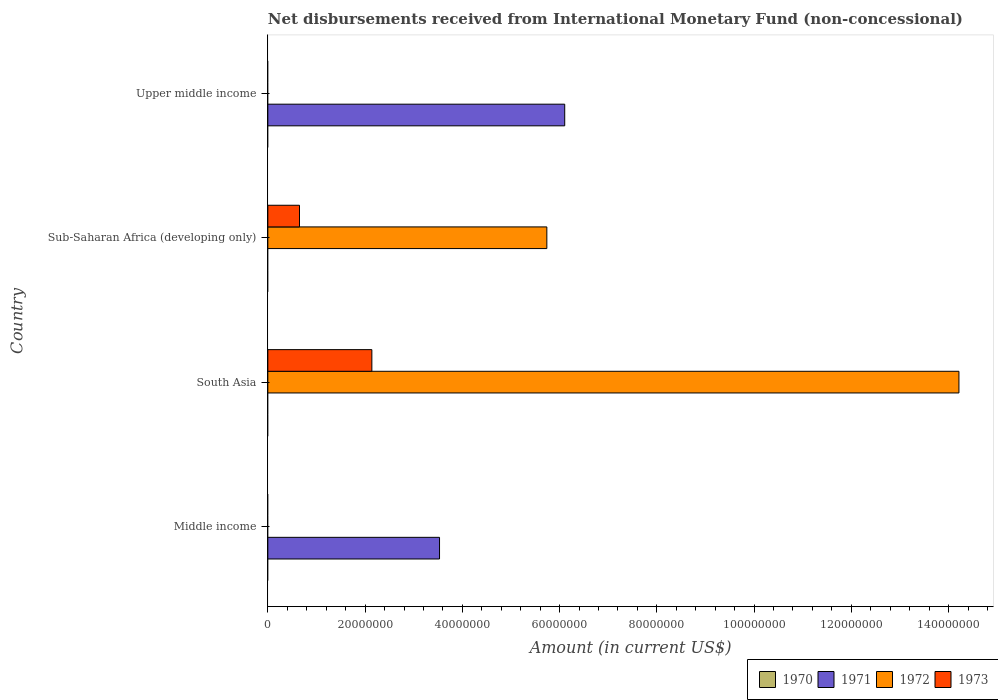How many different coloured bars are there?
Keep it short and to the point. 3. Are the number of bars on each tick of the Y-axis equal?
Your response must be concise. No. What is the label of the 1st group of bars from the top?
Make the answer very short. Upper middle income. In how many cases, is the number of bars for a given country not equal to the number of legend labels?
Your answer should be very brief. 4. What is the amount of disbursements received from International Monetary Fund in 1972 in South Asia?
Ensure brevity in your answer.  1.42e+08. Across all countries, what is the maximum amount of disbursements received from International Monetary Fund in 1971?
Provide a short and direct response. 6.11e+07. Across all countries, what is the minimum amount of disbursements received from International Monetary Fund in 1973?
Offer a very short reply. 0. In which country was the amount of disbursements received from International Monetary Fund in 1971 maximum?
Give a very brief answer. Upper middle income. What is the total amount of disbursements received from International Monetary Fund in 1970 in the graph?
Ensure brevity in your answer.  0. What is the difference between the amount of disbursements received from International Monetary Fund in 1972 in South Asia and that in Sub-Saharan Africa (developing only)?
Keep it short and to the point. 8.48e+07. What is the difference between the amount of disbursements received from International Monetary Fund in 1970 in Sub-Saharan Africa (developing only) and the amount of disbursements received from International Monetary Fund in 1973 in Upper middle income?
Offer a terse response. 0. What is the difference between the amount of disbursements received from International Monetary Fund in 1972 and amount of disbursements received from International Monetary Fund in 1973 in Sub-Saharan Africa (developing only)?
Offer a very short reply. 5.09e+07. What is the difference between the highest and the lowest amount of disbursements received from International Monetary Fund in 1973?
Keep it short and to the point. 2.14e+07. Is the sum of the amount of disbursements received from International Monetary Fund in 1972 in South Asia and Sub-Saharan Africa (developing only) greater than the maximum amount of disbursements received from International Monetary Fund in 1971 across all countries?
Make the answer very short. Yes. Is it the case that in every country, the sum of the amount of disbursements received from International Monetary Fund in 1972 and amount of disbursements received from International Monetary Fund in 1973 is greater than the sum of amount of disbursements received from International Monetary Fund in 1970 and amount of disbursements received from International Monetary Fund in 1971?
Make the answer very short. No. Is it the case that in every country, the sum of the amount of disbursements received from International Monetary Fund in 1970 and amount of disbursements received from International Monetary Fund in 1973 is greater than the amount of disbursements received from International Monetary Fund in 1971?
Your answer should be compact. No. What is the difference between two consecutive major ticks on the X-axis?
Keep it short and to the point. 2.00e+07. Are the values on the major ticks of X-axis written in scientific E-notation?
Keep it short and to the point. No. Does the graph contain grids?
Keep it short and to the point. No. Where does the legend appear in the graph?
Your response must be concise. Bottom right. How many legend labels are there?
Your response must be concise. 4. How are the legend labels stacked?
Your answer should be compact. Horizontal. What is the title of the graph?
Your response must be concise. Net disbursements received from International Monetary Fund (non-concessional). Does "1966" appear as one of the legend labels in the graph?
Offer a terse response. No. What is the Amount (in current US$) of 1971 in Middle income?
Your answer should be compact. 3.53e+07. What is the Amount (in current US$) of 1972 in Middle income?
Offer a terse response. 0. What is the Amount (in current US$) of 1973 in Middle income?
Offer a terse response. 0. What is the Amount (in current US$) in 1972 in South Asia?
Provide a short and direct response. 1.42e+08. What is the Amount (in current US$) in 1973 in South Asia?
Offer a terse response. 2.14e+07. What is the Amount (in current US$) of 1972 in Sub-Saharan Africa (developing only)?
Your answer should be compact. 5.74e+07. What is the Amount (in current US$) in 1973 in Sub-Saharan Africa (developing only)?
Your answer should be compact. 6.51e+06. What is the Amount (in current US$) in 1971 in Upper middle income?
Keep it short and to the point. 6.11e+07. What is the Amount (in current US$) in 1973 in Upper middle income?
Provide a succinct answer. 0. Across all countries, what is the maximum Amount (in current US$) of 1971?
Give a very brief answer. 6.11e+07. Across all countries, what is the maximum Amount (in current US$) of 1972?
Offer a very short reply. 1.42e+08. Across all countries, what is the maximum Amount (in current US$) of 1973?
Your answer should be very brief. 2.14e+07. Across all countries, what is the minimum Amount (in current US$) of 1971?
Keep it short and to the point. 0. Across all countries, what is the minimum Amount (in current US$) of 1972?
Offer a very short reply. 0. What is the total Amount (in current US$) in 1971 in the graph?
Your answer should be compact. 9.64e+07. What is the total Amount (in current US$) of 1972 in the graph?
Offer a terse response. 2.00e+08. What is the total Amount (in current US$) of 1973 in the graph?
Give a very brief answer. 2.79e+07. What is the difference between the Amount (in current US$) of 1971 in Middle income and that in Upper middle income?
Ensure brevity in your answer.  -2.57e+07. What is the difference between the Amount (in current US$) in 1972 in South Asia and that in Sub-Saharan Africa (developing only)?
Make the answer very short. 8.48e+07. What is the difference between the Amount (in current US$) in 1973 in South Asia and that in Sub-Saharan Africa (developing only)?
Provide a short and direct response. 1.49e+07. What is the difference between the Amount (in current US$) in 1971 in Middle income and the Amount (in current US$) in 1972 in South Asia?
Make the answer very short. -1.07e+08. What is the difference between the Amount (in current US$) of 1971 in Middle income and the Amount (in current US$) of 1973 in South Asia?
Ensure brevity in your answer.  1.39e+07. What is the difference between the Amount (in current US$) in 1971 in Middle income and the Amount (in current US$) in 1972 in Sub-Saharan Africa (developing only)?
Your response must be concise. -2.21e+07. What is the difference between the Amount (in current US$) in 1971 in Middle income and the Amount (in current US$) in 1973 in Sub-Saharan Africa (developing only)?
Offer a terse response. 2.88e+07. What is the difference between the Amount (in current US$) of 1972 in South Asia and the Amount (in current US$) of 1973 in Sub-Saharan Africa (developing only)?
Offer a terse response. 1.36e+08. What is the average Amount (in current US$) in 1971 per country?
Give a very brief answer. 2.41e+07. What is the average Amount (in current US$) of 1972 per country?
Give a very brief answer. 4.99e+07. What is the average Amount (in current US$) of 1973 per country?
Offer a terse response. 6.98e+06. What is the difference between the Amount (in current US$) of 1972 and Amount (in current US$) of 1973 in South Asia?
Ensure brevity in your answer.  1.21e+08. What is the difference between the Amount (in current US$) of 1972 and Amount (in current US$) of 1973 in Sub-Saharan Africa (developing only)?
Your response must be concise. 5.09e+07. What is the ratio of the Amount (in current US$) of 1971 in Middle income to that in Upper middle income?
Your answer should be compact. 0.58. What is the ratio of the Amount (in current US$) in 1972 in South Asia to that in Sub-Saharan Africa (developing only)?
Offer a very short reply. 2.48. What is the ratio of the Amount (in current US$) in 1973 in South Asia to that in Sub-Saharan Africa (developing only)?
Offer a very short reply. 3.29. What is the difference between the highest and the lowest Amount (in current US$) in 1971?
Keep it short and to the point. 6.11e+07. What is the difference between the highest and the lowest Amount (in current US$) of 1972?
Your response must be concise. 1.42e+08. What is the difference between the highest and the lowest Amount (in current US$) in 1973?
Your response must be concise. 2.14e+07. 